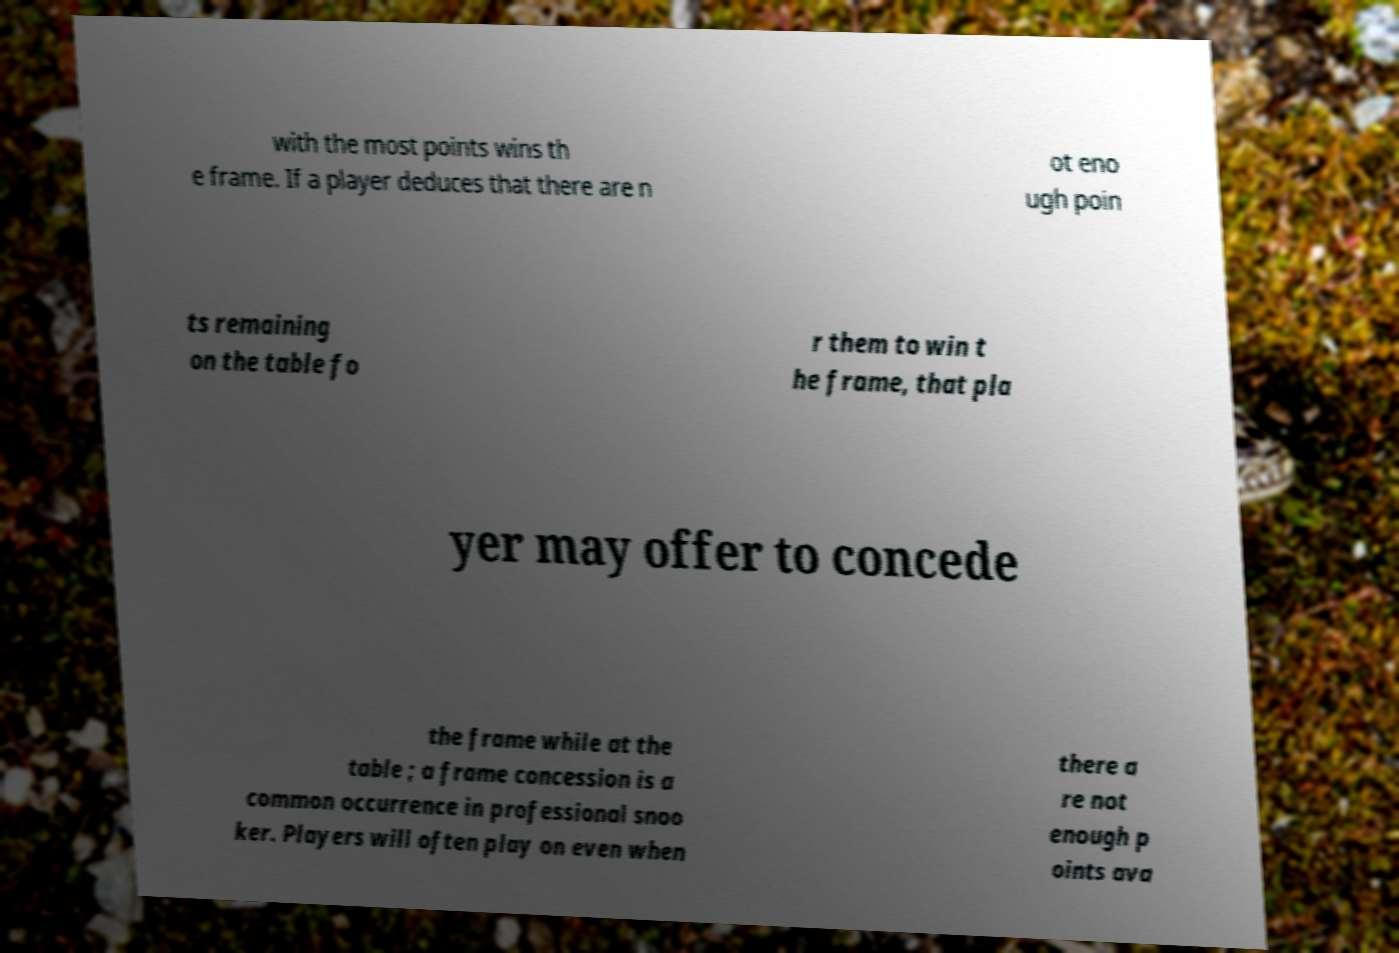I need the written content from this picture converted into text. Can you do that? with the most points wins th e frame. If a player deduces that there are n ot eno ugh poin ts remaining on the table fo r them to win t he frame, that pla yer may offer to concede the frame while at the table ; a frame concession is a common occurrence in professional snoo ker. Players will often play on even when there a re not enough p oints ava 